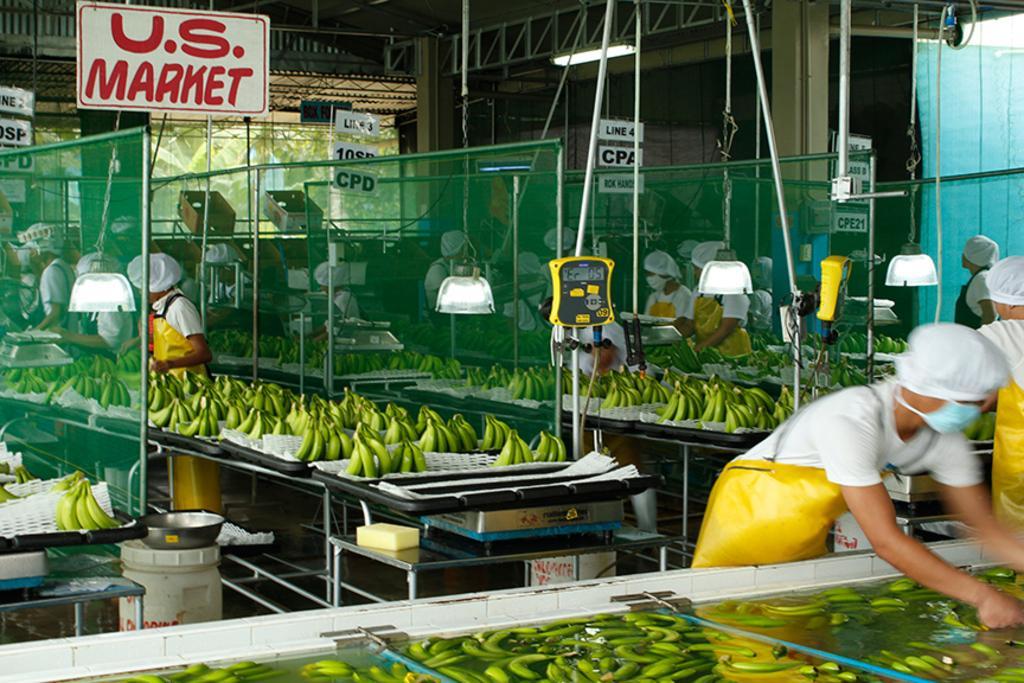How would you summarize this image in a sentence or two? In this picture, we can see a few people, and bananas on the plate, and we can see some bananas in the water, and we can see some containers, net, weighing machine, boards with text, poles, net, and we can see tables, dusters, trees and the ground. 